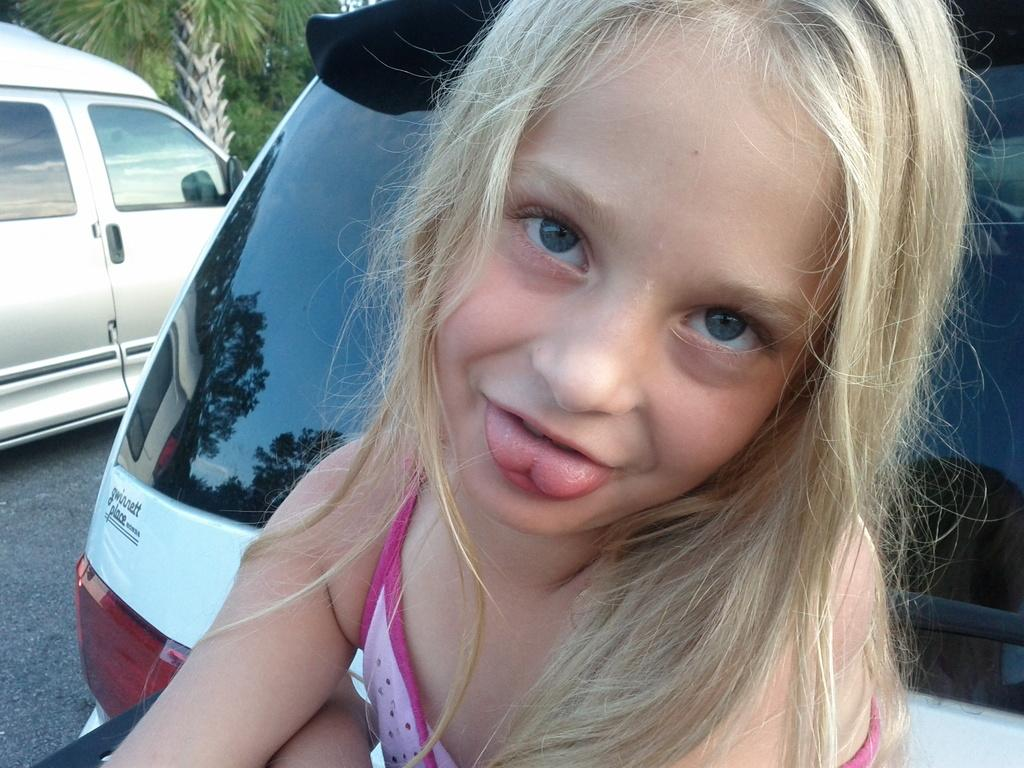Who is the main subject in the image? There is a girl in the image. What can be seen behind the girl? There are cars and trees behind the girl. What type of drum is the girl playing in the image? There is no drum present in the image; the girl is not playing any musical instrument. 